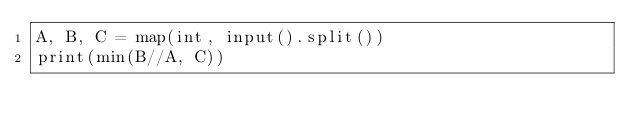<code> <loc_0><loc_0><loc_500><loc_500><_Python_>A, B, C = map(int, input().split())
print(min(B//A, C))
</code> 